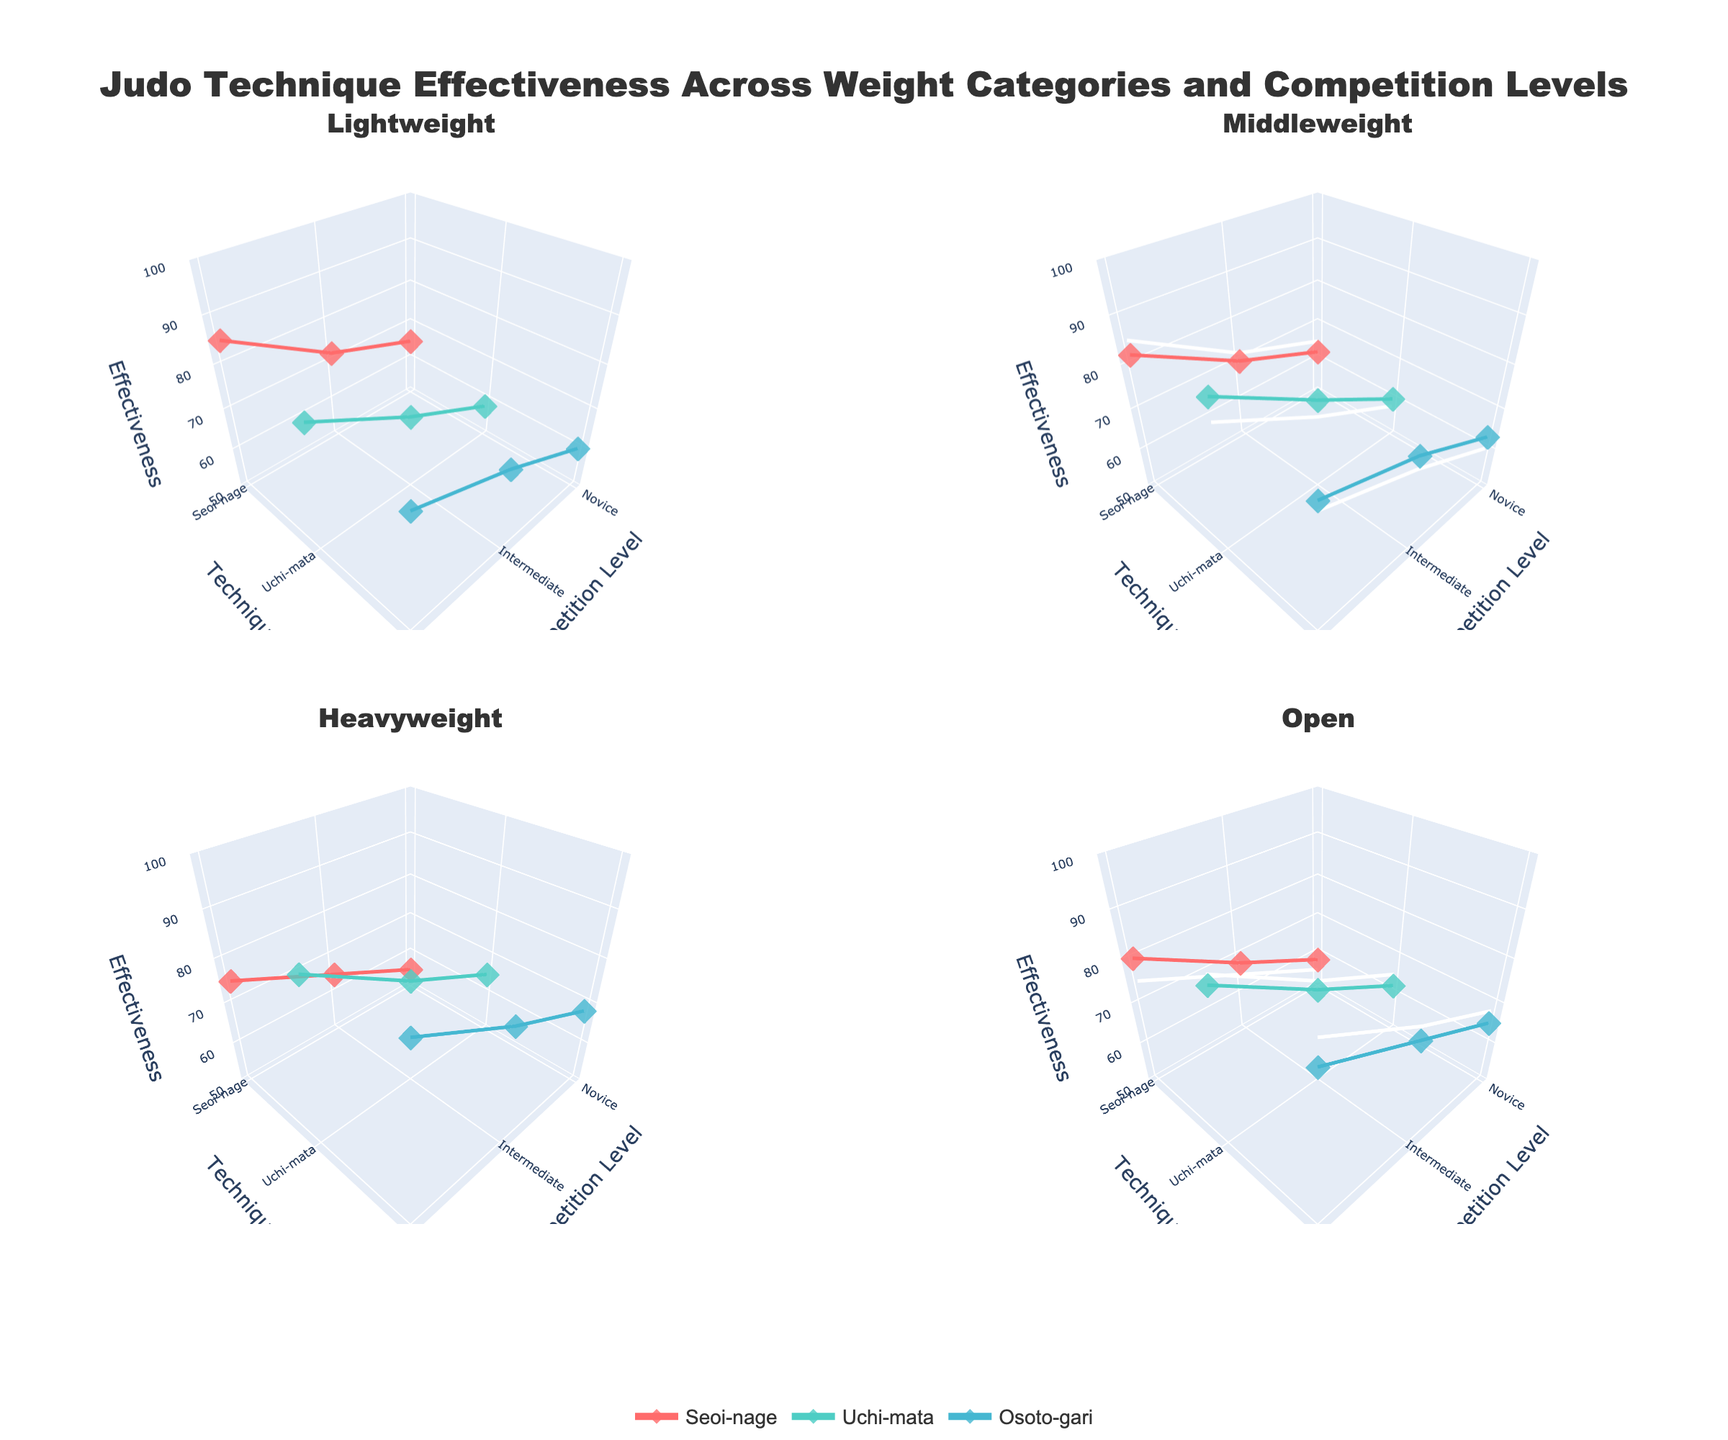What is the title of the plot? The title of the plot is located at the top center of the figure. It is written in a larger and bolder font compared to other texts.
Answer: Judo Technique Effectiveness Across Weight Categories and Competition Levels Which technique has the highest effectiveness for Elite competitors in the Heavyweight category? Look at the subplot for the Heavyweight category. For Elite competitors, compare the highest Z-axis value among the three techniques (Seoi-nage, Uchi-mata, Osoto-gari).
Answer: Osoto-gari Which weight category shows the least effectiveness for the Seoi-nage technique at the Novice level? Compare the Z-axis values for the Seoi-nage technique at the Novice level across all four subplots (Lightweight, Middleweight, Heavyweight, Open).
Answer: Heavyweight In the Middleweight category, what is the average effectiveness of the Uchi-mata technique across all competition levels? In the Middleweight category subplot, take the Z-axis values for Uchi-mata at Novice, Intermediate, and Elite levels. Calculate the average of these three values: (60 + 72 + 85) / 3.
Answer: 72.33 Does the effectiveness of Osoto-gari increase or decrease as the competition level goes up in the Lightweight category? In the Lightweight category subplot, observe the trend of the Z-axis values for Osoto-gari from Novice to Elite levels. If the values increase sequentially, then the effectiveness increases.
Answer: Increase Compare the effectiveness of Uchi-mata in the Open category with the effectiveness of Seoi-nage in the Middleweight category for Elite competitors. Which is higher? Locate the Z-axis value for Uchi-mata in the Open category and compare it with the Z-axis value for Seoi-nage in the Middleweight category at the Elite level.
Answer: Uchi-mata in Open category What is the difference in effectiveness of Seoi-nage between Intermediate and Elite competitors in the Lightweight category? In the Lightweight category subplot, subtract the Z-axis value of Seoi-nage at the Intermediate level from its value at the Elite level: 85 - 72.
Answer: 13 How many different weight categories are represented in the subplots? Count the number of subplot titles, each corresponding to a weight category. The subplot titles are displayed above each subplot.
Answer: 4 Which technique improves the most from Intermediate to Elite level in the Heavyweight category? Locate the Z-axis values for each technique in the Heavyweight category subplot at Intermediate and Elite levels, and compute the increase for each. The technique with the largest increase has the highest improvement.
Answer: Uchi-mata For Intermediate competitors, which weight category has the highest effectiveness for the Osoto-gari technique? Compare the Z-axis values for Osoto-gari at the Intermediate level across all four subplots (Lightweight, Middleweight, Heavyweight, Open).
Answer: Heavyweight 